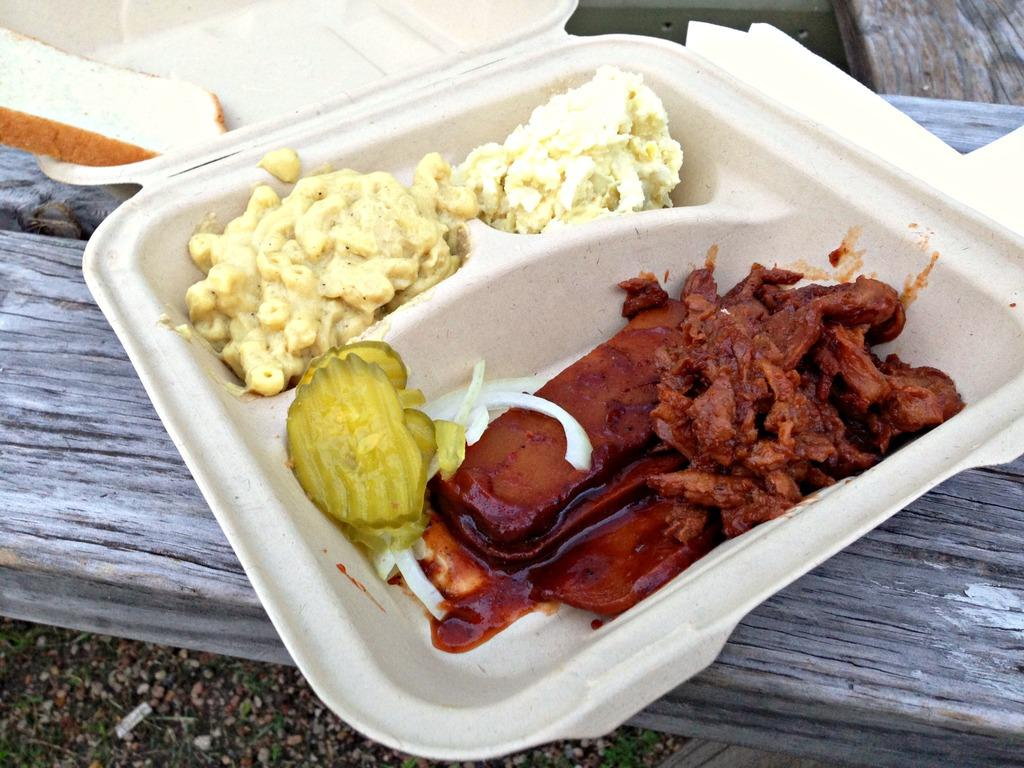What is inside the box that is visible in the image? There are food items in a box in the image. Where is the box located in the image? The box is placed on a wooden surface in the image. What can be seen at the bottom of the image? The ground is visible at the bottom of the image. Can you see any celery growing in the image? There is no celery visible in the image. What thoughts or ideas are present in the image? The image does not depict any thoughts or ideas; it is a visual representation of a box with food items on a wooden surface. 